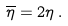Convert formula to latex. <formula><loc_0><loc_0><loc_500><loc_500>\overline { \eta } = 2 \eta \, .</formula> 